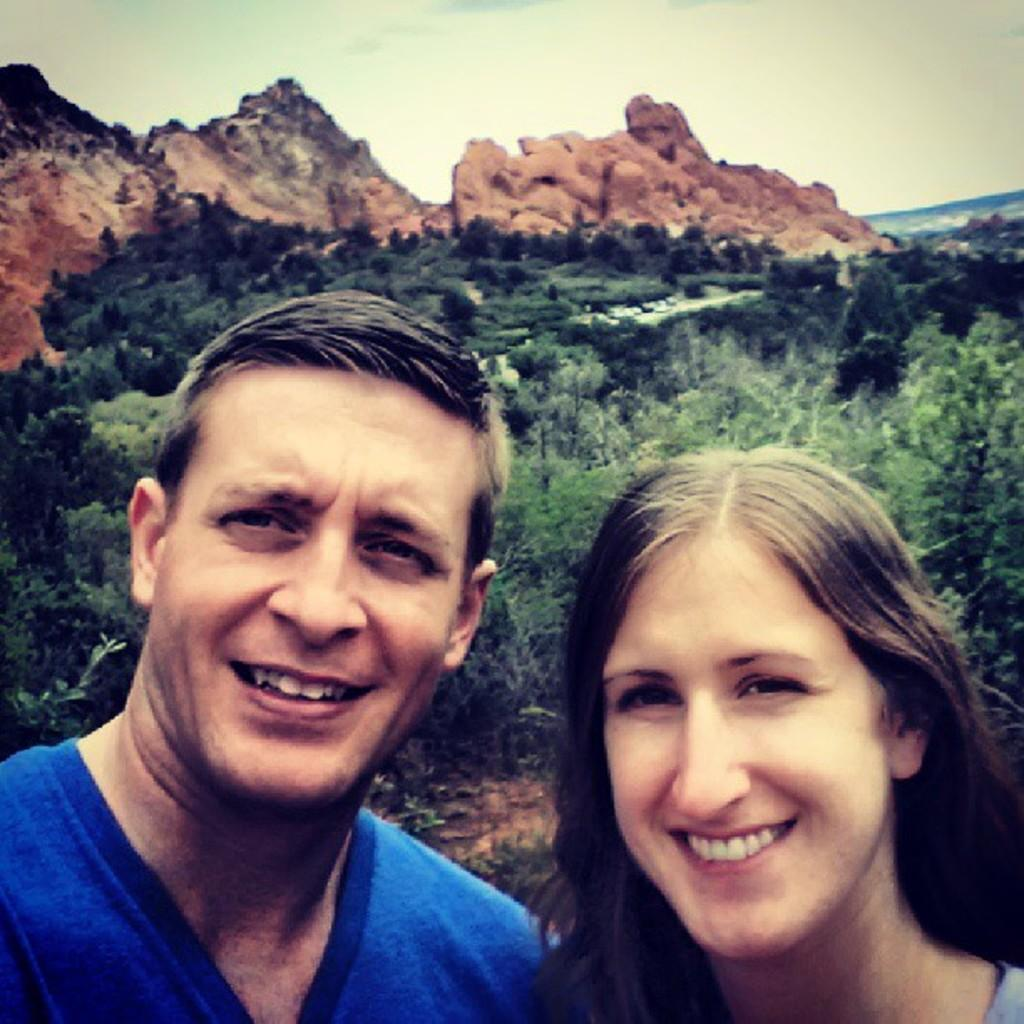Who is present in the image? There is a man and a woman in the image. What expressions do the man and woman have? Both the man and the woman are smiling. What can be seen in the background of the image? There are trees, a mountain, and the sky visible in the background of the image. What type of berry can be seen growing on the mountain in the image? There are no berries visible on the mountain in the image. What plot of land are the man and woman standing on in the image? The image does not provide information about the specific plot of land where the man and woman are standing. 